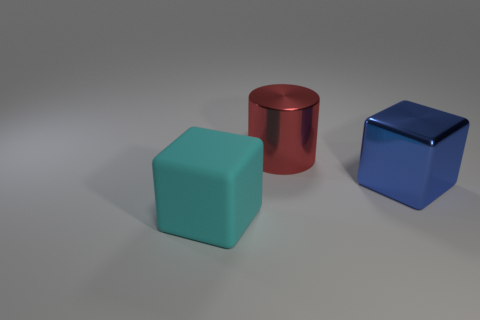Is there anything else that has the same material as the cyan thing?
Ensure brevity in your answer.  No. Is there another big cylinder of the same color as the large cylinder?
Ensure brevity in your answer.  No. The shiny object that is the same size as the blue shiny block is what color?
Make the answer very short. Red. Are the cube on the right side of the matte cube and the large cyan object made of the same material?
Your answer should be very brief. No. There is a shiny object in front of the large metal thing that is to the left of the big blue thing; is there a rubber block behind it?
Your response must be concise. No. There is a big thing behind the big blue metal block; is it the same shape as the big cyan matte object?
Provide a succinct answer. No. What shape is the metal thing that is behind the large cube on the right side of the large red object?
Provide a succinct answer. Cylinder. There is a block behind the cube that is to the left of the cube that is right of the cyan rubber thing; how big is it?
Provide a succinct answer. Large. There is a large rubber object that is the same shape as the blue metallic object; what is its color?
Your response must be concise. Cyan. Do the matte block and the blue block have the same size?
Keep it short and to the point. Yes. 